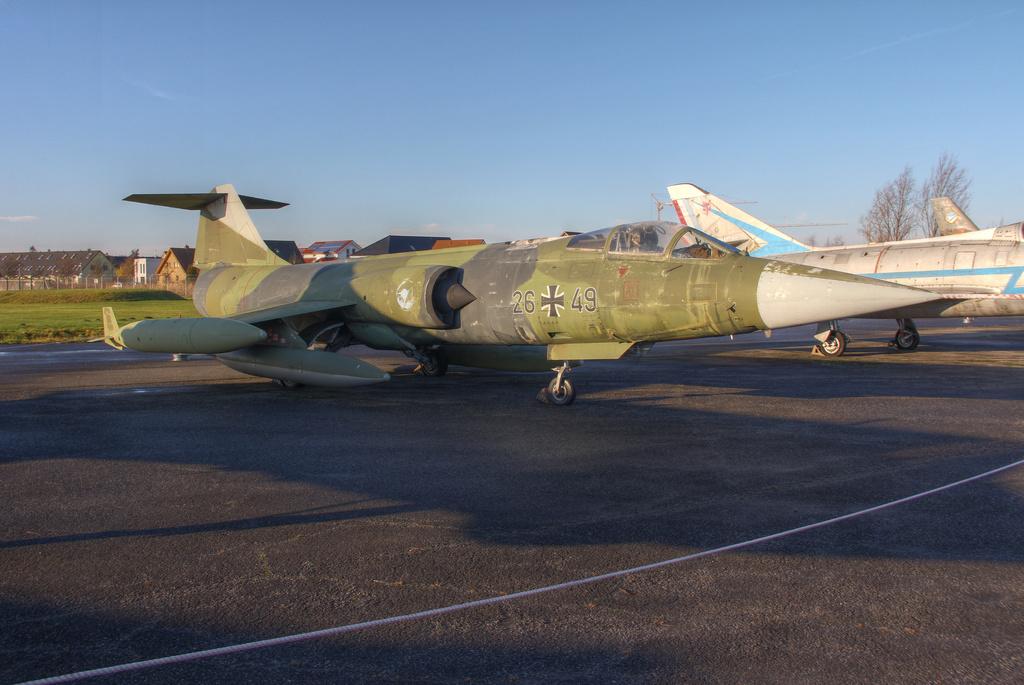What are the numbers of this jet?
Provide a succinct answer. 26 49. 